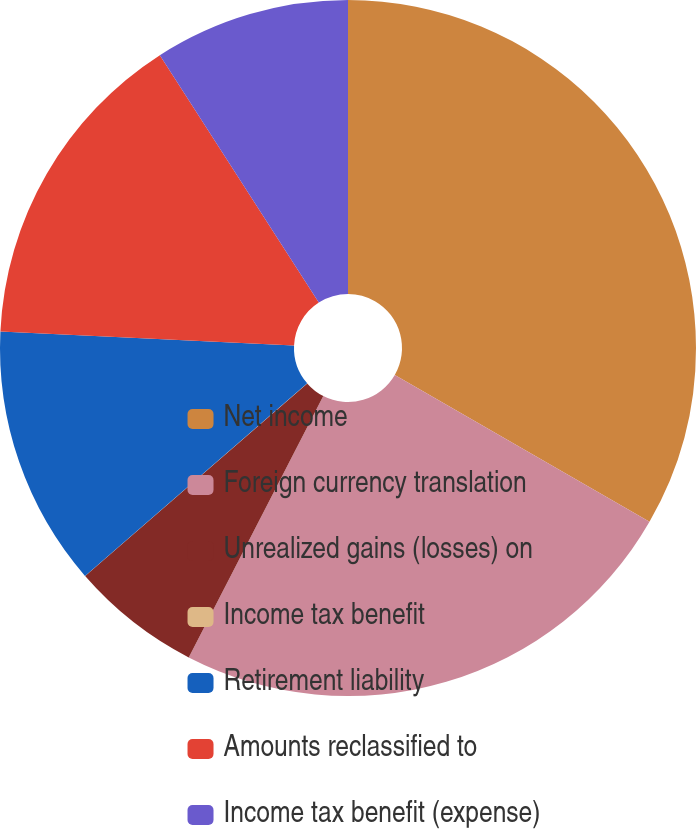Convert chart to OTSL. <chart><loc_0><loc_0><loc_500><loc_500><pie_chart><fcel>Net income<fcel>Foreign currency translation<fcel>Unrealized gains (losses) on<fcel>Income tax benefit<fcel>Retirement liability<fcel>Amounts reclassified to<fcel>Income tax benefit (expense)<nl><fcel>33.32%<fcel>24.24%<fcel>6.06%<fcel>0.01%<fcel>12.12%<fcel>15.15%<fcel>9.09%<nl></chart> 